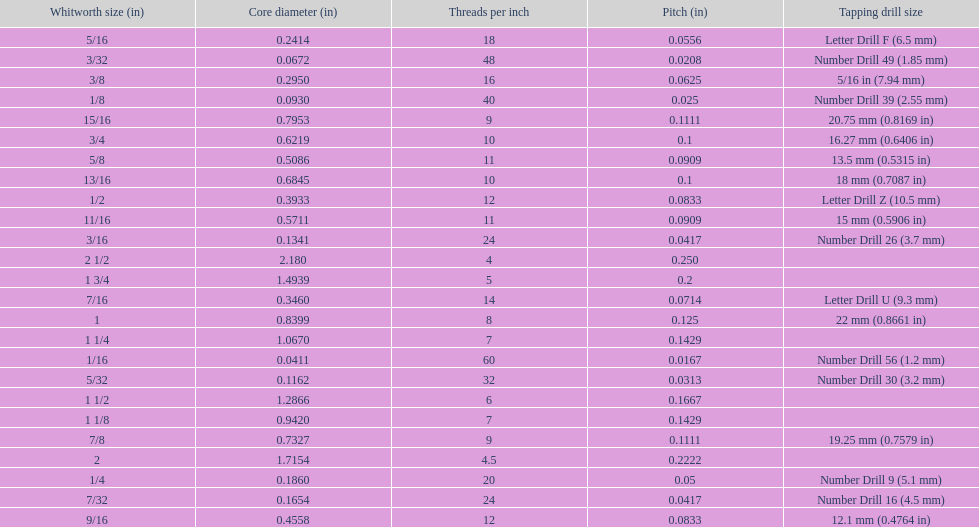What is the core diameter of the last whitworth thread size? 2.180. 